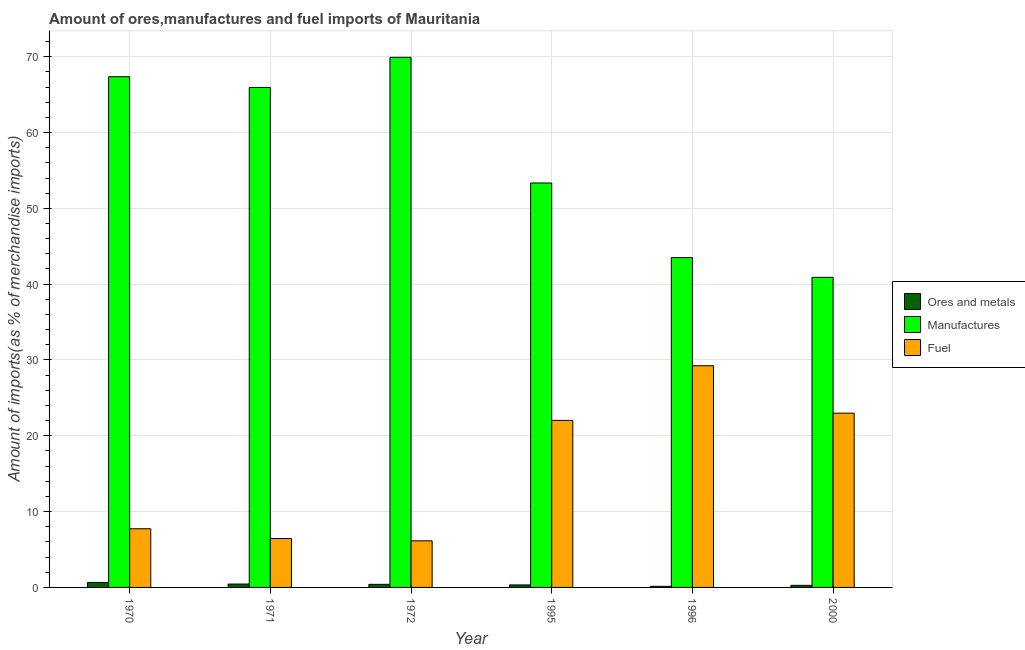How many bars are there on the 6th tick from the right?
Provide a short and direct response. 3. In how many cases, is the number of bars for a given year not equal to the number of legend labels?
Give a very brief answer. 0. What is the percentage of fuel imports in 1972?
Make the answer very short. 6.15. Across all years, what is the maximum percentage of fuel imports?
Offer a terse response. 29.24. Across all years, what is the minimum percentage of ores and metals imports?
Offer a terse response. 0.14. In which year was the percentage of ores and metals imports maximum?
Offer a terse response. 1970. In which year was the percentage of manufactures imports minimum?
Provide a succinct answer. 2000. What is the total percentage of fuel imports in the graph?
Offer a very short reply. 94.6. What is the difference between the percentage of ores and metals imports in 1970 and that in 1972?
Offer a terse response. 0.25. What is the difference between the percentage of fuel imports in 1996 and the percentage of manufactures imports in 1971?
Make the answer very short. 22.79. What is the average percentage of manufactures imports per year?
Your answer should be compact. 56.83. In the year 2000, what is the difference between the percentage of fuel imports and percentage of ores and metals imports?
Your answer should be compact. 0. In how many years, is the percentage of fuel imports greater than 62 %?
Provide a succinct answer. 0. What is the ratio of the percentage of ores and metals imports in 1970 to that in 1995?
Provide a succinct answer. 1.99. Is the percentage of ores and metals imports in 1970 less than that in 2000?
Make the answer very short. No. Is the difference between the percentage of manufactures imports in 1971 and 1996 greater than the difference between the percentage of ores and metals imports in 1971 and 1996?
Offer a very short reply. No. What is the difference between the highest and the second highest percentage of manufactures imports?
Your response must be concise. 2.56. What is the difference between the highest and the lowest percentage of manufactures imports?
Give a very brief answer. 29.02. Is the sum of the percentage of ores and metals imports in 1970 and 2000 greater than the maximum percentage of manufactures imports across all years?
Keep it short and to the point. Yes. What does the 1st bar from the left in 1996 represents?
Make the answer very short. Ores and metals. What does the 1st bar from the right in 1971 represents?
Ensure brevity in your answer.  Fuel. Is it the case that in every year, the sum of the percentage of ores and metals imports and percentage of manufactures imports is greater than the percentage of fuel imports?
Provide a short and direct response. Yes. Are all the bars in the graph horizontal?
Your response must be concise. No. How many years are there in the graph?
Offer a very short reply. 6. What is the difference between two consecutive major ticks on the Y-axis?
Your answer should be compact. 10. Are the values on the major ticks of Y-axis written in scientific E-notation?
Your answer should be very brief. No. Does the graph contain any zero values?
Provide a short and direct response. No. What is the title of the graph?
Keep it short and to the point. Amount of ores,manufactures and fuel imports of Mauritania. Does "Ages 50+" appear as one of the legend labels in the graph?
Offer a terse response. No. What is the label or title of the Y-axis?
Offer a very short reply. Amount of imports(as % of merchandise imports). What is the Amount of imports(as % of merchandise imports) in Ores and metals in 1970?
Your answer should be compact. 0.66. What is the Amount of imports(as % of merchandise imports) in Manufactures in 1970?
Your answer should be very brief. 67.36. What is the Amount of imports(as % of merchandise imports) in Fuel in 1970?
Ensure brevity in your answer.  7.74. What is the Amount of imports(as % of merchandise imports) in Ores and metals in 1971?
Your response must be concise. 0.45. What is the Amount of imports(as % of merchandise imports) in Manufactures in 1971?
Give a very brief answer. 65.94. What is the Amount of imports(as % of merchandise imports) in Fuel in 1971?
Keep it short and to the point. 6.45. What is the Amount of imports(as % of merchandise imports) in Ores and metals in 1972?
Offer a very short reply. 0.41. What is the Amount of imports(as % of merchandise imports) in Manufactures in 1972?
Ensure brevity in your answer.  69.92. What is the Amount of imports(as % of merchandise imports) of Fuel in 1972?
Your response must be concise. 6.15. What is the Amount of imports(as % of merchandise imports) of Ores and metals in 1995?
Your answer should be compact. 0.33. What is the Amount of imports(as % of merchandise imports) of Manufactures in 1995?
Keep it short and to the point. 53.35. What is the Amount of imports(as % of merchandise imports) in Fuel in 1995?
Your answer should be compact. 22.03. What is the Amount of imports(as % of merchandise imports) of Ores and metals in 1996?
Your answer should be compact. 0.14. What is the Amount of imports(as % of merchandise imports) of Manufactures in 1996?
Ensure brevity in your answer.  43.51. What is the Amount of imports(as % of merchandise imports) of Fuel in 1996?
Your response must be concise. 29.24. What is the Amount of imports(as % of merchandise imports) of Ores and metals in 2000?
Ensure brevity in your answer.  0.27. What is the Amount of imports(as % of merchandise imports) in Manufactures in 2000?
Keep it short and to the point. 40.9. What is the Amount of imports(as % of merchandise imports) of Fuel in 2000?
Ensure brevity in your answer.  22.99. Across all years, what is the maximum Amount of imports(as % of merchandise imports) in Ores and metals?
Give a very brief answer. 0.66. Across all years, what is the maximum Amount of imports(as % of merchandise imports) in Manufactures?
Offer a very short reply. 69.92. Across all years, what is the maximum Amount of imports(as % of merchandise imports) in Fuel?
Provide a succinct answer. 29.24. Across all years, what is the minimum Amount of imports(as % of merchandise imports) in Ores and metals?
Your answer should be very brief. 0.14. Across all years, what is the minimum Amount of imports(as % of merchandise imports) in Manufactures?
Make the answer very short. 40.9. Across all years, what is the minimum Amount of imports(as % of merchandise imports) in Fuel?
Offer a very short reply. 6.15. What is the total Amount of imports(as % of merchandise imports) in Ores and metals in the graph?
Offer a terse response. 2.26. What is the total Amount of imports(as % of merchandise imports) of Manufactures in the graph?
Offer a very short reply. 340.97. What is the total Amount of imports(as % of merchandise imports) in Fuel in the graph?
Your answer should be compact. 94.6. What is the difference between the Amount of imports(as % of merchandise imports) of Ores and metals in 1970 and that in 1971?
Your answer should be very brief. 0.21. What is the difference between the Amount of imports(as % of merchandise imports) of Manufactures in 1970 and that in 1971?
Provide a short and direct response. 1.41. What is the difference between the Amount of imports(as % of merchandise imports) in Fuel in 1970 and that in 1971?
Your answer should be compact. 1.29. What is the difference between the Amount of imports(as % of merchandise imports) of Ores and metals in 1970 and that in 1972?
Ensure brevity in your answer.  0.25. What is the difference between the Amount of imports(as % of merchandise imports) of Manufactures in 1970 and that in 1972?
Offer a very short reply. -2.56. What is the difference between the Amount of imports(as % of merchandise imports) of Fuel in 1970 and that in 1972?
Provide a succinct answer. 1.59. What is the difference between the Amount of imports(as % of merchandise imports) of Ores and metals in 1970 and that in 1995?
Your response must be concise. 0.33. What is the difference between the Amount of imports(as % of merchandise imports) in Manufactures in 1970 and that in 1995?
Provide a short and direct response. 14.01. What is the difference between the Amount of imports(as % of merchandise imports) in Fuel in 1970 and that in 1995?
Ensure brevity in your answer.  -14.29. What is the difference between the Amount of imports(as % of merchandise imports) of Ores and metals in 1970 and that in 1996?
Keep it short and to the point. 0.52. What is the difference between the Amount of imports(as % of merchandise imports) in Manufactures in 1970 and that in 1996?
Offer a very short reply. 23.85. What is the difference between the Amount of imports(as % of merchandise imports) of Fuel in 1970 and that in 1996?
Provide a succinct answer. -21.5. What is the difference between the Amount of imports(as % of merchandise imports) in Ores and metals in 1970 and that in 2000?
Ensure brevity in your answer.  0.38. What is the difference between the Amount of imports(as % of merchandise imports) of Manufactures in 1970 and that in 2000?
Your answer should be compact. 26.46. What is the difference between the Amount of imports(as % of merchandise imports) of Fuel in 1970 and that in 2000?
Keep it short and to the point. -15.25. What is the difference between the Amount of imports(as % of merchandise imports) in Ores and metals in 1971 and that in 1972?
Give a very brief answer. 0.04. What is the difference between the Amount of imports(as % of merchandise imports) of Manufactures in 1971 and that in 1972?
Your response must be concise. -3.97. What is the difference between the Amount of imports(as % of merchandise imports) of Fuel in 1971 and that in 1972?
Offer a very short reply. 0.3. What is the difference between the Amount of imports(as % of merchandise imports) in Ores and metals in 1971 and that in 1995?
Your answer should be compact. 0.11. What is the difference between the Amount of imports(as % of merchandise imports) in Manufactures in 1971 and that in 1995?
Your answer should be compact. 12.6. What is the difference between the Amount of imports(as % of merchandise imports) of Fuel in 1971 and that in 1995?
Offer a very short reply. -15.58. What is the difference between the Amount of imports(as % of merchandise imports) in Ores and metals in 1971 and that in 1996?
Keep it short and to the point. 0.3. What is the difference between the Amount of imports(as % of merchandise imports) in Manufactures in 1971 and that in 1996?
Your answer should be compact. 22.44. What is the difference between the Amount of imports(as % of merchandise imports) in Fuel in 1971 and that in 1996?
Your response must be concise. -22.79. What is the difference between the Amount of imports(as % of merchandise imports) of Ores and metals in 1971 and that in 2000?
Provide a short and direct response. 0.17. What is the difference between the Amount of imports(as % of merchandise imports) of Manufactures in 1971 and that in 2000?
Keep it short and to the point. 25.04. What is the difference between the Amount of imports(as % of merchandise imports) in Fuel in 1971 and that in 2000?
Your response must be concise. -16.53. What is the difference between the Amount of imports(as % of merchandise imports) of Ores and metals in 1972 and that in 1995?
Your response must be concise. 0.08. What is the difference between the Amount of imports(as % of merchandise imports) of Manufactures in 1972 and that in 1995?
Ensure brevity in your answer.  16.57. What is the difference between the Amount of imports(as % of merchandise imports) in Fuel in 1972 and that in 1995?
Offer a terse response. -15.88. What is the difference between the Amount of imports(as % of merchandise imports) in Ores and metals in 1972 and that in 1996?
Offer a very short reply. 0.26. What is the difference between the Amount of imports(as % of merchandise imports) of Manufactures in 1972 and that in 1996?
Your response must be concise. 26.41. What is the difference between the Amount of imports(as % of merchandise imports) in Fuel in 1972 and that in 1996?
Keep it short and to the point. -23.09. What is the difference between the Amount of imports(as % of merchandise imports) of Ores and metals in 1972 and that in 2000?
Your answer should be compact. 0.13. What is the difference between the Amount of imports(as % of merchandise imports) of Manufactures in 1972 and that in 2000?
Provide a short and direct response. 29.02. What is the difference between the Amount of imports(as % of merchandise imports) of Fuel in 1972 and that in 2000?
Offer a very short reply. -16.84. What is the difference between the Amount of imports(as % of merchandise imports) in Ores and metals in 1995 and that in 1996?
Provide a succinct answer. 0.19. What is the difference between the Amount of imports(as % of merchandise imports) of Manufactures in 1995 and that in 1996?
Make the answer very short. 9.84. What is the difference between the Amount of imports(as % of merchandise imports) in Fuel in 1995 and that in 1996?
Give a very brief answer. -7.21. What is the difference between the Amount of imports(as % of merchandise imports) of Ores and metals in 1995 and that in 2000?
Keep it short and to the point. 0.06. What is the difference between the Amount of imports(as % of merchandise imports) in Manufactures in 1995 and that in 2000?
Ensure brevity in your answer.  12.44. What is the difference between the Amount of imports(as % of merchandise imports) of Fuel in 1995 and that in 2000?
Your answer should be very brief. -0.95. What is the difference between the Amount of imports(as % of merchandise imports) of Ores and metals in 1996 and that in 2000?
Offer a very short reply. -0.13. What is the difference between the Amount of imports(as % of merchandise imports) of Manufactures in 1996 and that in 2000?
Keep it short and to the point. 2.61. What is the difference between the Amount of imports(as % of merchandise imports) of Fuel in 1996 and that in 2000?
Offer a terse response. 6.25. What is the difference between the Amount of imports(as % of merchandise imports) of Ores and metals in 1970 and the Amount of imports(as % of merchandise imports) of Manufactures in 1971?
Give a very brief answer. -65.29. What is the difference between the Amount of imports(as % of merchandise imports) in Ores and metals in 1970 and the Amount of imports(as % of merchandise imports) in Fuel in 1971?
Your response must be concise. -5.79. What is the difference between the Amount of imports(as % of merchandise imports) of Manufactures in 1970 and the Amount of imports(as % of merchandise imports) of Fuel in 1971?
Ensure brevity in your answer.  60.91. What is the difference between the Amount of imports(as % of merchandise imports) in Ores and metals in 1970 and the Amount of imports(as % of merchandise imports) in Manufactures in 1972?
Provide a short and direct response. -69.26. What is the difference between the Amount of imports(as % of merchandise imports) of Ores and metals in 1970 and the Amount of imports(as % of merchandise imports) of Fuel in 1972?
Give a very brief answer. -5.49. What is the difference between the Amount of imports(as % of merchandise imports) in Manufactures in 1970 and the Amount of imports(as % of merchandise imports) in Fuel in 1972?
Your answer should be compact. 61.21. What is the difference between the Amount of imports(as % of merchandise imports) in Ores and metals in 1970 and the Amount of imports(as % of merchandise imports) in Manufactures in 1995?
Your answer should be very brief. -52.69. What is the difference between the Amount of imports(as % of merchandise imports) in Ores and metals in 1970 and the Amount of imports(as % of merchandise imports) in Fuel in 1995?
Give a very brief answer. -21.37. What is the difference between the Amount of imports(as % of merchandise imports) of Manufactures in 1970 and the Amount of imports(as % of merchandise imports) of Fuel in 1995?
Provide a succinct answer. 45.33. What is the difference between the Amount of imports(as % of merchandise imports) of Ores and metals in 1970 and the Amount of imports(as % of merchandise imports) of Manufactures in 1996?
Your answer should be very brief. -42.85. What is the difference between the Amount of imports(as % of merchandise imports) in Ores and metals in 1970 and the Amount of imports(as % of merchandise imports) in Fuel in 1996?
Ensure brevity in your answer.  -28.58. What is the difference between the Amount of imports(as % of merchandise imports) of Manufactures in 1970 and the Amount of imports(as % of merchandise imports) of Fuel in 1996?
Provide a short and direct response. 38.12. What is the difference between the Amount of imports(as % of merchandise imports) of Ores and metals in 1970 and the Amount of imports(as % of merchandise imports) of Manufactures in 2000?
Provide a short and direct response. -40.24. What is the difference between the Amount of imports(as % of merchandise imports) of Ores and metals in 1970 and the Amount of imports(as % of merchandise imports) of Fuel in 2000?
Offer a terse response. -22.33. What is the difference between the Amount of imports(as % of merchandise imports) of Manufactures in 1970 and the Amount of imports(as % of merchandise imports) of Fuel in 2000?
Ensure brevity in your answer.  44.37. What is the difference between the Amount of imports(as % of merchandise imports) in Ores and metals in 1971 and the Amount of imports(as % of merchandise imports) in Manufactures in 1972?
Provide a short and direct response. -69.47. What is the difference between the Amount of imports(as % of merchandise imports) of Ores and metals in 1971 and the Amount of imports(as % of merchandise imports) of Fuel in 1972?
Offer a very short reply. -5.7. What is the difference between the Amount of imports(as % of merchandise imports) in Manufactures in 1971 and the Amount of imports(as % of merchandise imports) in Fuel in 1972?
Keep it short and to the point. 59.8. What is the difference between the Amount of imports(as % of merchandise imports) of Ores and metals in 1971 and the Amount of imports(as % of merchandise imports) of Manufactures in 1995?
Give a very brief answer. -52.9. What is the difference between the Amount of imports(as % of merchandise imports) of Ores and metals in 1971 and the Amount of imports(as % of merchandise imports) of Fuel in 1995?
Offer a very short reply. -21.58. What is the difference between the Amount of imports(as % of merchandise imports) of Manufactures in 1971 and the Amount of imports(as % of merchandise imports) of Fuel in 1995?
Your answer should be very brief. 43.91. What is the difference between the Amount of imports(as % of merchandise imports) in Ores and metals in 1971 and the Amount of imports(as % of merchandise imports) in Manufactures in 1996?
Your answer should be very brief. -43.06. What is the difference between the Amount of imports(as % of merchandise imports) of Ores and metals in 1971 and the Amount of imports(as % of merchandise imports) of Fuel in 1996?
Your response must be concise. -28.79. What is the difference between the Amount of imports(as % of merchandise imports) of Manufactures in 1971 and the Amount of imports(as % of merchandise imports) of Fuel in 1996?
Provide a short and direct response. 36.7. What is the difference between the Amount of imports(as % of merchandise imports) of Ores and metals in 1971 and the Amount of imports(as % of merchandise imports) of Manufactures in 2000?
Ensure brevity in your answer.  -40.45. What is the difference between the Amount of imports(as % of merchandise imports) of Ores and metals in 1971 and the Amount of imports(as % of merchandise imports) of Fuel in 2000?
Your answer should be compact. -22.54. What is the difference between the Amount of imports(as % of merchandise imports) of Manufactures in 1971 and the Amount of imports(as % of merchandise imports) of Fuel in 2000?
Ensure brevity in your answer.  42.96. What is the difference between the Amount of imports(as % of merchandise imports) in Ores and metals in 1972 and the Amount of imports(as % of merchandise imports) in Manufactures in 1995?
Provide a short and direct response. -52.94. What is the difference between the Amount of imports(as % of merchandise imports) in Ores and metals in 1972 and the Amount of imports(as % of merchandise imports) in Fuel in 1995?
Give a very brief answer. -21.62. What is the difference between the Amount of imports(as % of merchandise imports) of Manufactures in 1972 and the Amount of imports(as % of merchandise imports) of Fuel in 1995?
Your answer should be compact. 47.89. What is the difference between the Amount of imports(as % of merchandise imports) of Ores and metals in 1972 and the Amount of imports(as % of merchandise imports) of Manufactures in 1996?
Offer a terse response. -43.1. What is the difference between the Amount of imports(as % of merchandise imports) of Ores and metals in 1972 and the Amount of imports(as % of merchandise imports) of Fuel in 1996?
Your answer should be compact. -28.83. What is the difference between the Amount of imports(as % of merchandise imports) of Manufactures in 1972 and the Amount of imports(as % of merchandise imports) of Fuel in 1996?
Provide a short and direct response. 40.68. What is the difference between the Amount of imports(as % of merchandise imports) of Ores and metals in 1972 and the Amount of imports(as % of merchandise imports) of Manufactures in 2000?
Make the answer very short. -40.49. What is the difference between the Amount of imports(as % of merchandise imports) in Ores and metals in 1972 and the Amount of imports(as % of merchandise imports) in Fuel in 2000?
Offer a very short reply. -22.58. What is the difference between the Amount of imports(as % of merchandise imports) of Manufactures in 1972 and the Amount of imports(as % of merchandise imports) of Fuel in 2000?
Keep it short and to the point. 46.93. What is the difference between the Amount of imports(as % of merchandise imports) of Ores and metals in 1995 and the Amount of imports(as % of merchandise imports) of Manufactures in 1996?
Keep it short and to the point. -43.17. What is the difference between the Amount of imports(as % of merchandise imports) in Ores and metals in 1995 and the Amount of imports(as % of merchandise imports) in Fuel in 1996?
Ensure brevity in your answer.  -28.91. What is the difference between the Amount of imports(as % of merchandise imports) in Manufactures in 1995 and the Amount of imports(as % of merchandise imports) in Fuel in 1996?
Give a very brief answer. 24.1. What is the difference between the Amount of imports(as % of merchandise imports) in Ores and metals in 1995 and the Amount of imports(as % of merchandise imports) in Manufactures in 2000?
Your answer should be very brief. -40.57. What is the difference between the Amount of imports(as % of merchandise imports) of Ores and metals in 1995 and the Amount of imports(as % of merchandise imports) of Fuel in 2000?
Provide a short and direct response. -22.65. What is the difference between the Amount of imports(as % of merchandise imports) in Manufactures in 1995 and the Amount of imports(as % of merchandise imports) in Fuel in 2000?
Provide a short and direct response. 30.36. What is the difference between the Amount of imports(as % of merchandise imports) in Ores and metals in 1996 and the Amount of imports(as % of merchandise imports) in Manufactures in 2000?
Keep it short and to the point. -40.76. What is the difference between the Amount of imports(as % of merchandise imports) of Ores and metals in 1996 and the Amount of imports(as % of merchandise imports) of Fuel in 2000?
Your answer should be very brief. -22.84. What is the difference between the Amount of imports(as % of merchandise imports) in Manufactures in 1996 and the Amount of imports(as % of merchandise imports) in Fuel in 2000?
Make the answer very short. 20.52. What is the average Amount of imports(as % of merchandise imports) of Ores and metals per year?
Ensure brevity in your answer.  0.38. What is the average Amount of imports(as % of merchandise imports) of Manufactures per year?
Give a very brief answer. 56.83. What is the average Amount of imports(as % of merchandise imports) of Fuel per year?
Your answer should be very brief. 15.77. In the year 1970, what is the difference between the Amount of imports(as % of merchandise imports) in Ores and metals and Amount of imports(as % of merchandise imports) in Manufactures?
Your answer should be compact. -66.7. In the year 1970, what is the difference between the Amount of imports(as % of merchandise imports) of Ores and metals and Amount of imports(as % of merchandise imports) of Fuel?
Make the answer very short. -7.08. In the year 1970, what is the difference between the Amount of imports(as % of merchandise imports) of Manufactures and Amount of imports(as % of merchandise imports) of Fuel?
Your answer should be very brief. 59.62. In the year 1971, what is the difference between the Amount of imports(as % of merchandise imports) in Ores and metals and Amount of imports(as % of merchandise imports) in Manufactures?
Your answer should be very brief. -65.5. In the year 1971, what is the difference between the Amount of imports(as % of merchandise imports) in Ores and metals and Amount of imports(as % of merchandise imports) in Fuel?
Ensure brevity in your answer.  -6.01. In the year 1971, what is the difference between the Amount of imports(as % of merchandise imports) of Manufactures and Amount of imports(as % of merchandise imports) of Fuel?
Offer a very short reply. 59.49. In the year 1972, what is the difference between the Amount of imports(as % of merchandise imports) in Ores and metals and Amount of imports(as % of merchandise imports) in Manufactures?
Make the answer very short. -69.51. In the year 1972, what is the difference between the Amount of imports(as % of merchandise imports) of Ores and metals and Amount of imports(as % of merchandise imports) of Fuel?
Offer a very short reply. -5.74. In the year 1972, what is the difference between the Amount of imports(as % of merchandise imports) in Manufactures and Amount of imports(as % of merchandise imports) in Fuel?
Offer a terse response. 63.77. In the year 1995, what is the difference between the Amount of imports(as % of merchandise imports) in Ores and metals and Amount of imports(as % of merchandise imports) in Manufactures?
Provide a succinct answer. -53.01. In the year 1995, what is the difference between the Amount of imports(as % of merchandise imports) of Ores and metals and Amount of imports(as % of merchandise imports) of Fuel?
Keep it short and to the point. -21.7. In the year 1995, what is the difference between the Amount of imports(as % of merchandise imports) in Manufactures and Amount of imports(as % of merchandise imports) in Fuel?
Offer a terse response. 31.31. In the year 1996, what is the difference between the Amount of imports(as % of merchandise imports) of Ores and metals and Amount of imports(as % of merchandise imports) of Manufactures?
Keep it short and to the point. -43.36. In the year 1996, what is the difference between the Amount of imports(as % of merchandise imports) of Ores and metals and Amount of imports(as % of merchandise imports) of Fuel?
Offer a very short reply. -29.1. In the year 1996, what is the difference between the Amount of imports(as % of merchandise imports) in Manufactures and Amount of imports(as % of merchandise imports) in Fuel?
Give a very brief answer. 14.27. In the year 2000, what is the difference between the Amount of imports(as % of merchandise imports) of Ores and metals and Amount of imports(as % of merchandise imports) of Manufactures?
Keep it short and to the point. -40.63. In the year 2000, what is the difference between the Amount of imports(as % of merchandise imports) of Ores and metals and Amount of imports(as % of merchandise imports) of Fuel?
Your answer should be compact. -22.71. In the year 2000, what is the difference between the Amount of imports(as % of merchandise imports) of Manufactures and Amount of imports(as % of merchandise imports) of Fuel?
Provide a succinct answer. 17.92. What is the ratio of the Amount of imports(as % of merchandise imports) in Ores and metals in 1970 to that in 1971?
Offer a terse response. 1.48. What is the ratio of the Amount of imports(as % of merchandise imports) in Manufactures in 1970 to that in 1971?
Make the answer very short. 1.02. What is the ratio of the Amount of imports(as % of merchandise imports) in Fuel in 1970 to that in 1971?
Make the answer very short. 1.2. What is the ratio of the Amount of imports(as % of merchandise imports) in Ores and metals in 1970 to that in 1972?
Offer a very short reply. 1.62. What is the ratio of the Amount of imports(as % of merchandise imports) of Manufactures in 1970 to that in 1972?
Provide a short and direct response. 0.96. What is the ratio of the Amount of imports(as % of merchandise imports) of Fuel in 1970 to that in 1972?
Give a very brief answer. 1.26. What is the ratio of the Amount of imports(as % of merchandise imports) of Ores and metals in 1970 to that in 1995?
Your answer should be very brief. 1.99. What is the ratio of the Amount of imports(as % of merchandise imports) in Manufactures in 1970 to that in 1995?
Provide a short and direct response. 1.26. What is the ratio of the Amount of imports(as % of merchandise imports) in Fuel in 1970 to that in 1995?
Make the answer very short. 0.35. What is the ratio of the Amount of imports(as % of merchandise imports) of Ores and metals in 1970 to that in 1996?
Your answer should be compact. 4.6. What is the ratio of the Amount of imports(as % of merchandise imports) in Manufactures in 1970 to that in 1996?
Provide a succinct answer. 1.55. What is the ratio of the Amount of imports(as % of merchandise imports) in Fuel in 1970 to that in 1996?
Your answer should be very brief. 0.26. What is the ratio of the Amount of imports(as % of merchandise imports) in Ores and metals in 1970 to that in 2000?
Provide a succinct answer. 2.4. What is the ratio of the Amount of imports(as % of merchandise imports) in Manufactures in 1970 to that in 2000?
Offer a terse response. 1.65. What is the ratio of the Amount of imports(as % of merchandise imports) in Fuel in 1970 to that in 2000?
Provide a succinct answer. 0.34. What is the ratio of the Amount of imports(as % of merchandise imports) in Ores and metals in 1971 to that in 1972?
Give a very brief answer. 1.09. What is the ratio of the Amount of imports(as % of merchandise imports) in Manufactures in 1971 to that in 1972?
Your response must be concise. 0.94. What is the ratio of the Amount of imports(as % of merchandise imports) in Fuel in 1971 to that in 1972?
Keep it short and to the point. 1.05. What is the ratio of the Amount of imports(as % of merchandise imports) in Ores and metals in 1971 to that in 1995?
Keep it short and to the point. 1.35. What is the ratio of the Amount of imports(as % of merchandise imports) of Manufactures in 1971 to that in 1995?
Your answer should be compact. 1.24. What is the ratio of the Amount of imports(as % of merchandise imports) of Fuel in 1971 to that in 1995?
Provide a succinct answer. 0.29. What is the ratio of the Amount of imports(as % of merchandise imports) in Ores and metals in 1971 to that in 1996?
Provide a short and direct response. 3.12. What is the ratio of the Amount of imports(as % of merchandise imports) in Manufactures in 1971 to that in 1996?
Make the answer very short. 1.52. What is the ratio of the Amount of imports(as % of merchandise imports) in Fuel in 1971 to that in 1996?
Keep it short and to the point. 0.22. What is the ratio of the Amount of imports(as % of merchandise imports) in Ores and metals in 1971 to that in 2000?
Keep it short and to the point. 1.63. What is the ratio of the Amount of imports(as % of merchandise imports) in Manufactures in 1971 to that in 2000?
Your response must be concise. 1.61. What is the ratio of the Amount of imports(as % of merchandise imports) in Fuel in 1971 to that in 2000?
Provide a short and direct response. 0.28. What is the ratio of the Amount of imports(as % of merchandise imports) of Ores and metals in 1972 to that in 1995?
Keep it short and to the point. 1.23. What is the ratio of the Amount of imports(as % of merchandise imports) in Manufactures in 1972 to that in 1995?
Provide a succinct answer. 1.31. What is the ratio of the Amount of imports(as % of merchandise imports) in Fuel in 1972 to that in 1995?
Provide a succinct answer. 0.28. What is the ratio of the Amount of imports(as % of merchandise imports) in Ores and metals in 1972 to that in 1996?
Offer a very short reply. 2.85. What is the ratio of the Amount of imports(as % of merchandise imports) of Manufactures in 1972 to that in 1996?
Offer a very short reply. 1.61. What is the ratio of the Amount of imports(as % of merchandise imports) of Fuel in 1972 to that in 1996?
Your answer should be compact. 0.21. What is the ratio of the Amount of imports(as % of merchandise imports) of Ores and metals in 1972 to that in 2000?
Keep it short and to the point. 1.49. What is the ratio of the Amount of imports(as % of merchandise imports) of Manufactures in 1972 to that in 2000?
Your answer should be compact. 1.71. What is the ratio of the Amount of imports(as % of merchandise imports) in Fuel in 1972 to that in 2000?
Your response must be concise. 0.27. What is the ratio of the Amount of imports(as % of merchandise imports) in Ores and metals in 1995 to that in 1996?
Give a very brief answer. 2.32. What is the ratio of the Amount of imports(as % of merchandise imports) in Manufactures in 1995 to that in 1996?
Your response must be concise. 1.23. What is the ratio of the Amount of imports(as % of merchandise imports) of Fuel in 1995 to that in 1996?
Keep it short and to the point. 0.75. What is the ratio of the Amount of imports(as % of merchandise imports) of Ores and metals in 1995 to that in 2000?
Your answer should be very brief. 1.21. What is the ratio of the Amount of imports(as % of merchandise imports) of Manufactures in 1995 to that in 2000?
Your answer should be very brief. 1.3. What is the ratio of the Amount of imports(as % of merchandise imports) in Fuel in 1995 to that in 2000?
Make the answer very short. 0.96. What is the ratio of the Amount of imports(as % of merchandise imports) in Ores and metals in 1996 to that in 2000?
Keep it short and to the point. 0.52. What is the ratio of the Amount of imports(as % of merchandise imports) of Manufactures in 1996 to that in 2000?
Offer a very short reply. 1.06. What is the ratio of the Amount of imports(as % of merchandise imports) of Fuel in 1996 to that in 2000?
Provide a succinct answer. 1.27. What is the difference between the highest and the second highest Amount of imports(as % of merchandise imports) in Ores and metals?
Offer a terse response. 0.21. What is the difference between the highest and the second highest Amount of imports(as % of merchandise imports) of Manufactures?
Your answer should be very brief. 2.56. What is the difference between the highest and the second highest Amount of imports(as % of merchandise imports) in Fuel?
Provide a succinct answer. 6.25. What is the difference between the highest and the lowest Amount of imports(as % of merchandise imports) of Ores and metals?
Provide a short and direct response. 0.52. What is the difference between the highest and the lowest Amount of imports(as % of merchandise imports) of Manufactures?
Your answer should be compact. 29.02. What is the difference between the highest and the lowest Amount of imports(as % of merchandise imports) of Fuel?
Give a very brief answer. 23.09. 